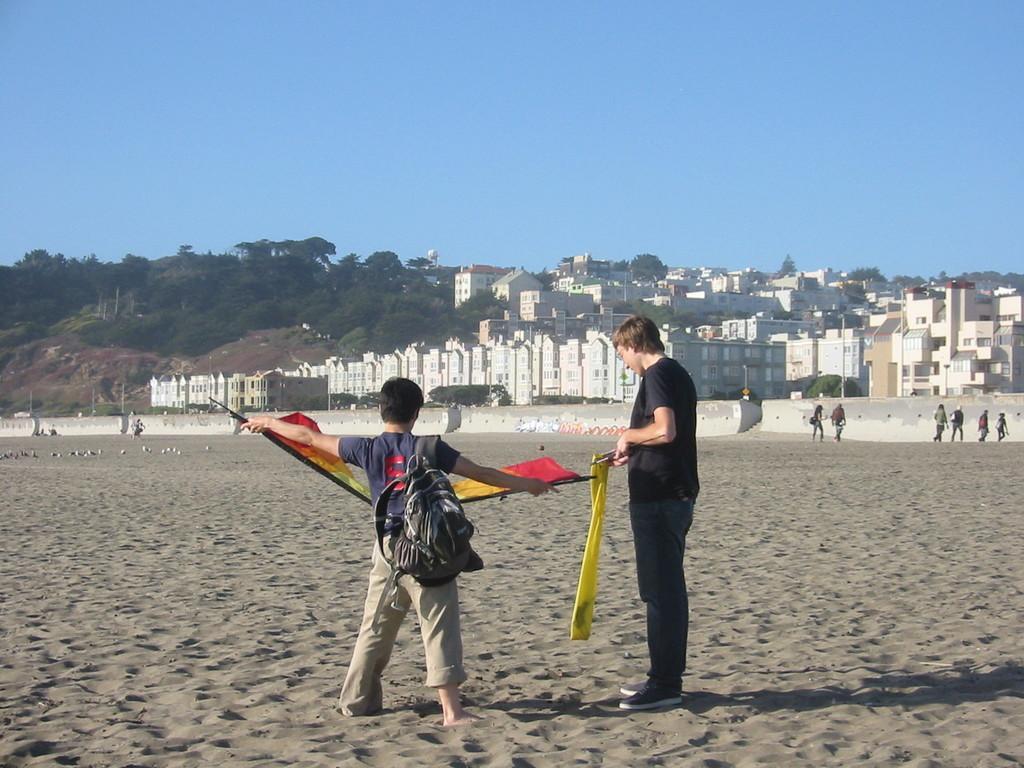How would you summarize this image in a sentence or two? In this picture I can see few people walking and I can see a boy wore a bag and he is holding couple of flags and I can see another man on the side and looks like a flag in his hand and I can see a blue sky. 